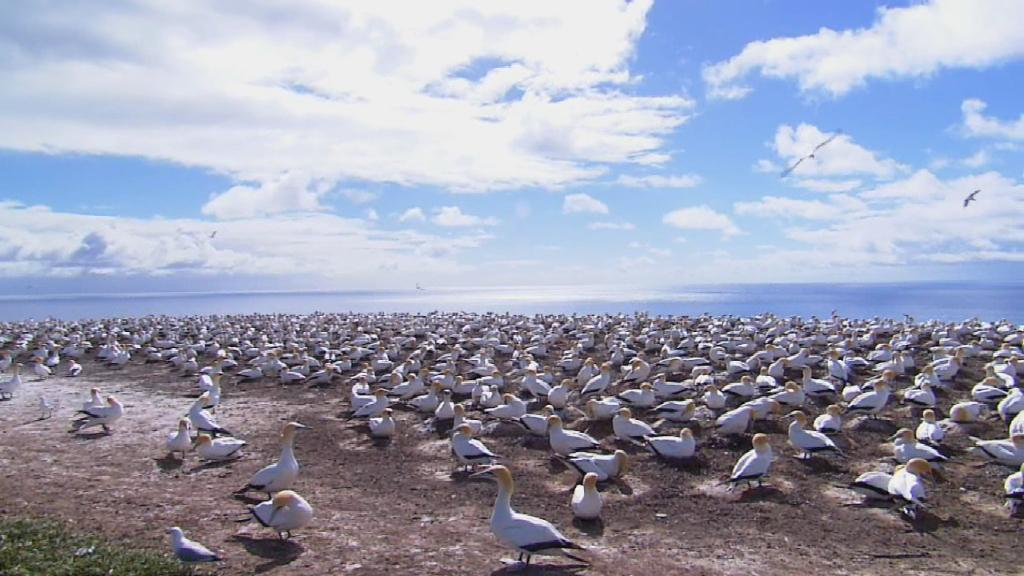What type of birds are in the image? There are white color birds in the image. Where are the birds located in the image? Some birds are on the ground, and some birds are flying in the air. What can be seen in the background of the image? There is water and the sky visible in the background of the image. Are there any women playing on the playground in the image? There is no playground or women present in the image; it features white color birds in various locations. 